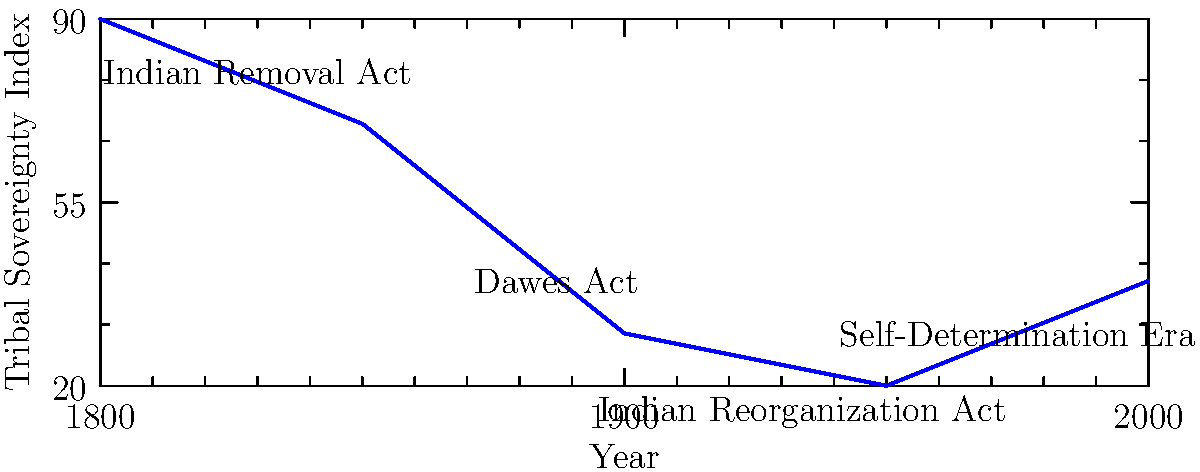Based on the vector-based timeline graph, which historical event appears to have had the most significant positive impact on tribal sovereignty in the United States? To answer this question, we need to analyze the graph and identify the points where there are significant changes in the Tribal Sovereignty Index:

1. The graph shows the Tribal Sovereignty Index from 1800 to 2000.
2. We can see several key events marked on the timeline:
   a. Indian Removal Act (1830)
   b. Dawes Act (1887)
   c. Indian Reorganization Act (1934)
   d. Self-Determination Era (begins around 1975)

3. Analyzing the trend:
   - From 1800 to 1830, there's a slight decline in sovereignty.
   - A steeper decline occurs between 1830 and 1887, likely due to the Indian Removal Act and subsequent policies.
   - The decline continues until around 1934.
   - After 1934, there's a slight upturn, but the most significant positive change occurs around 1975.

4. The most substantial positive change in the graph coincides with the beginning of the Self-Determination Era around 1975.

5. This era, marked by policies like the Indian Self-Determination and Education Assistance Act of 1975, gave tribes more control over their affairs and resources.

Therefore, based on the graph, the Self-Determination Era appears to have had the most significant positive impact on tribal sovereignty.
Answer: Self-Determination Era 